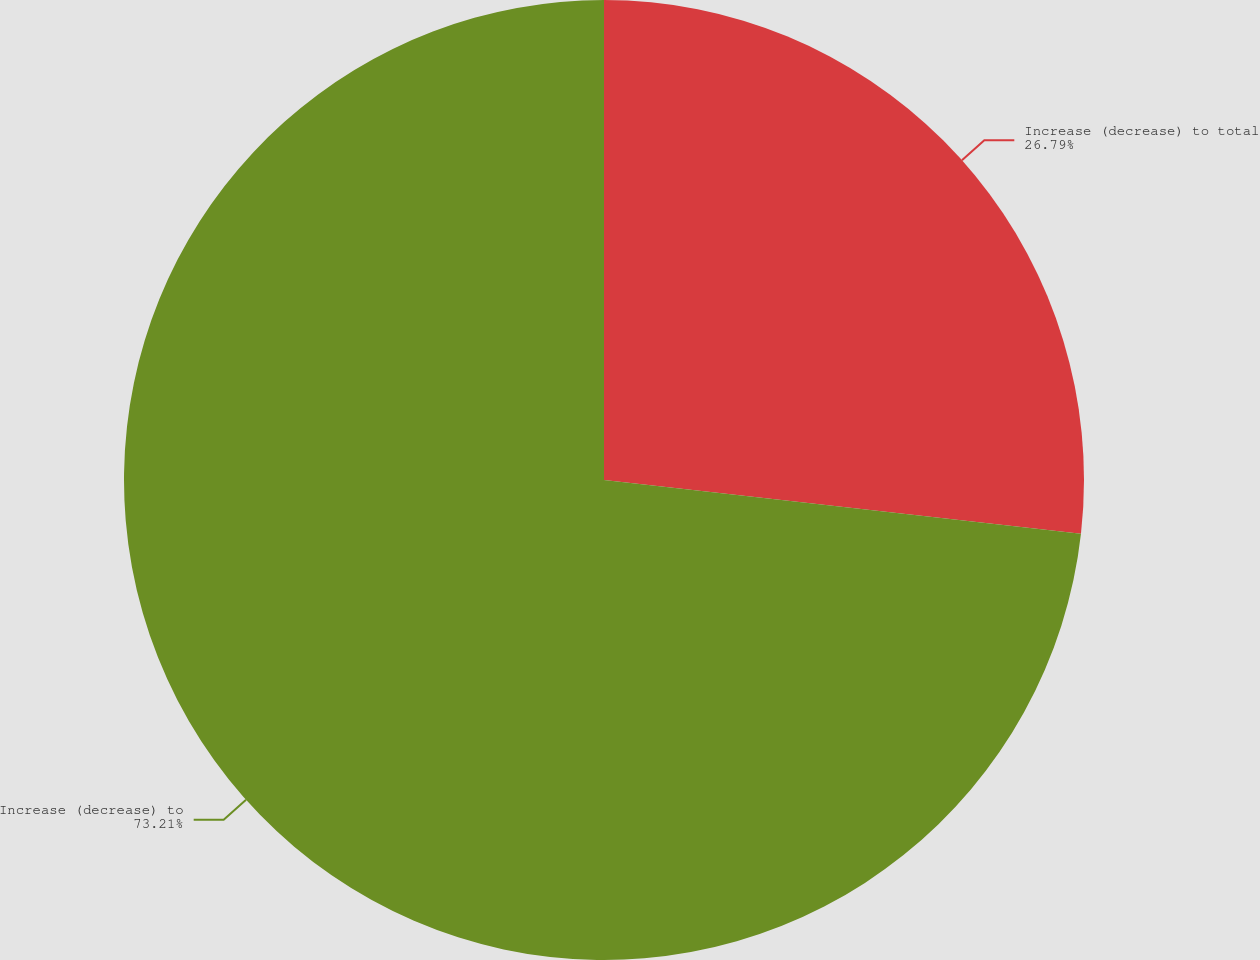Convert chart. <chart><loc_0><loc_0><loc_500><loc_500><pie_chart><fcel>Increase (decrease) to total<fcel>Increase (decrease) to<nl><fcel>26.79%<fcel>73.21%<nl></chart> 